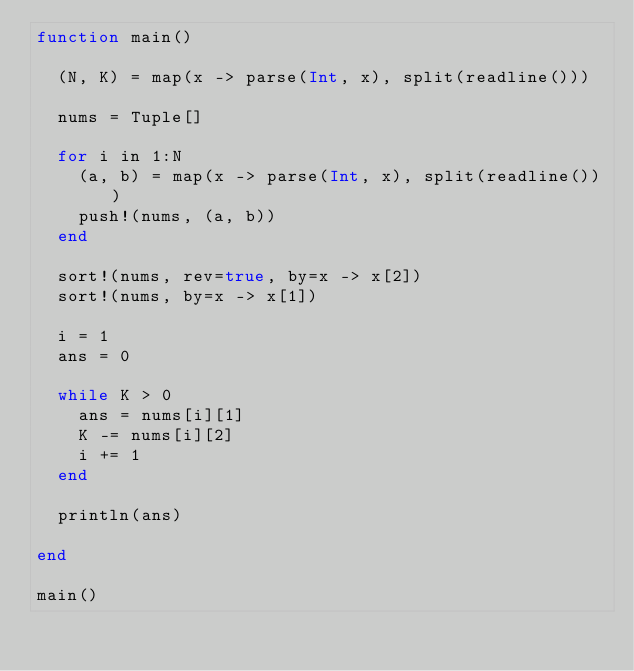Convert code to text. <code><loc_0><loc_0><loc_500><loc_500><_Julia_>function main()
  
  (N, K) = map(x -> parse(Int, x), split(readline()))
  
  nums = Tuple[]
  
  for i in 1:N
    (a, b) = map(x -> parse(Int, x), split(readline()))
    push!(nums, (a, b))
  end
  
  sort!(nums, rev=true, by=x -> x[2])
  sort!(nums, by=x -> x[1])
  
  i = 1
  ans = 0
  
  while K > 0
    ans = nums[i][1]
    K -= nums[i][2]
    i += 1
  end

  println(ans)
  
end

main()</code> 